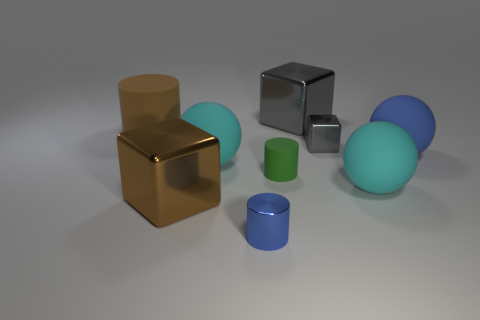What number of red things are either tiny things or metallic cylinders?
Keep it short and to the point. 0. Is the material of the large brown cylinder the same as the tiny object behind the blue rubber sphere?
Your answer should be compact. No. Are there an equal number of big blue matte spheres that are on the left side of the brown rubber object and cyan things in front of the brown block?
Your answer should be compact. Yes. Do the brown metallic object and the gray thing that is in front of the big rubber cylinder have the same size?
Offer a very short reply. No. Is the number of tiny shiny cylinders that are in front of the tiny green object greater than the number of small matte cylinders?
Provide a succinct answer. No. What number of gray spheres are the same size as the blue matte sphere?
Your response must be concise. 0. Do the ball in front of the green rubber cylinder and the blue object that is to the right of the large gray shiny cube have the same size?
Provide a succinct answer. Yes. Are there more small gray metal cubes that are on the left side of the tiny green thing than large brown cylinders on the right side of the small blue metal thing?
Ensure brevity in your answer.  No. What number of large brown matte things are the same shape as the tiny blue thing?
Offer a very short reply. 1. There is a blue sphere that is the same size as the brown block; what material is it?
Your answer should be very brief. Rubber. 